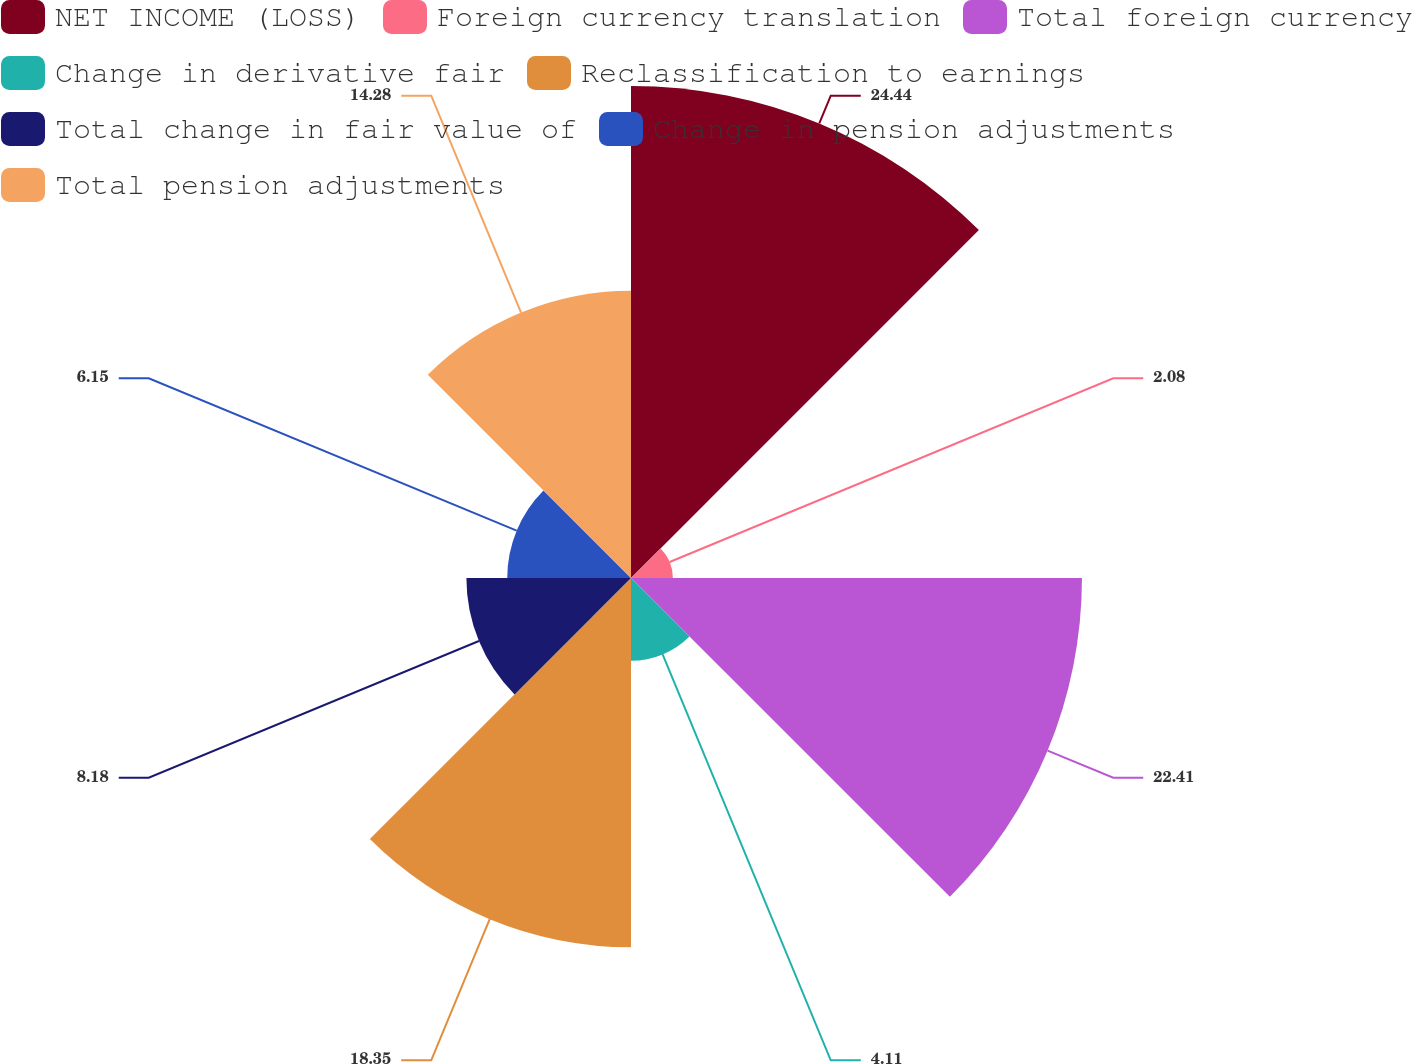Convert chart. <chart><loc_0><loc_0><loc_500><loc_500><pie_chart><fcel>NET INCOME (LOSS)<fcel>Foreign currency translation<fcel>Total foreign currency<fcel>Change in derivative fair<fcel>Reclassification to earnings<fcel>Total change in fair value of<fcel>Change in pension adjustments<fcel>Total pension adjustments<nl><fcel>24.45%<fcel>2.08%<fcel>22.41%<fcel>4.11%<fcel>18.35%<fcel>8.18%<fcel>6.15%<fcel>14.28%<nl></chart> 